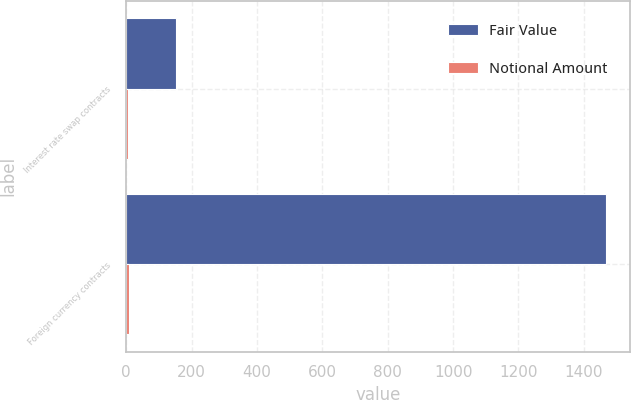Convert chart. <chart><loc_0><loc_0><loc_500><loc_500><stacked_bar_chart><ecel><fcel>Interest rate swap contracts<fcel>Foreign currency contracts<nl><fcel>Fair Value<fcel>152.2<fcel>1468.4<nl><fcel>Notional Amount<fcel>4.8<fcel>8.5<nl></chart> 